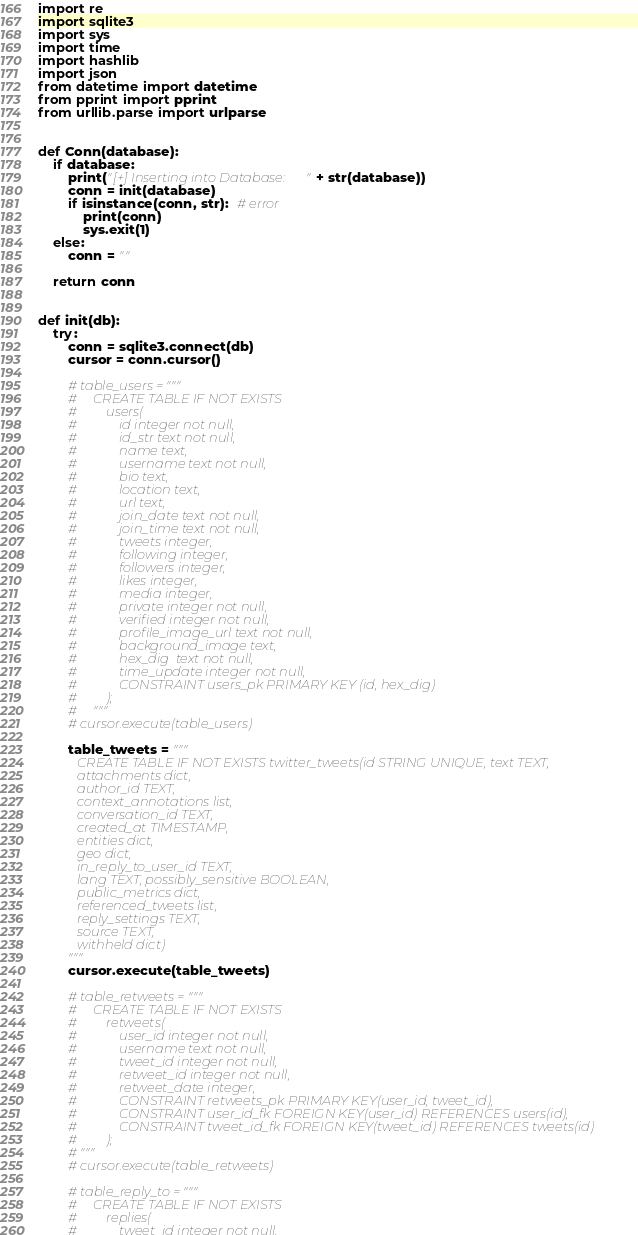<code> <loc_0><loc_0><loc_500><loc_500><_Python_>import re
import sqlite3
import sys
import time
import hashlib
import json
from datetime import datetime
from pprint import pprint
from urllib.parse import urlparse


def Conn(database):
    if database:
        print("[+] Inserting into Database: " + str(database))
        conn = init(database)
        if isinstance(conn, str):  # error
            print(conn)
            sys.exit(1)
    else:
        conn = ""

    return conn


def init(db):
    try:
        conn = sqlite3.connect(db)
        cursor = conn.cursor()

        # table_users = """
        #     CREATE TABLE IF NOT EXISTS
        #         users(
        #             id integer not null,
        #             id_str text not null,
        #             name text,
        #             username text not null,
        #             bio text,
        #             location text,
        #             url text,
        #             join_date text not null,
        #             join_time text not null,
        #             tweets integer,
        #             following integer,
        #             followers integer,
        #             likes integer,
        #             media integer,
        #             private integer not null,
        #             verified integer not null,
        #             profile_image_url text not null,
        #             background_image text,
        #             hex_dig  text not null,
        #             time_update integer not null,
        #             CONSTRAINT users_pk PRIMARY KEY (id, hex_dig)
        #         );
        #     """
        # cursor.execute(table_users)

        table_tweets = """
            CREATE TABLE IF NOT EXISTS twitter_tweets(id STRING UNIQUE, text TEXT,
            attachments dict,
            author_id TEXT,
            context_annotations list,
            conversation_id TEXT,
            created_at TIMESTAMP,
            entities dict,
            geo dict, 
            in_reply_to_user_id TEXT,
            lang TEXT, possibly_sensitive BOOLEAN,
            public_metrics dict,
            referenced_tweets list,
            reply_settings TEXT,
            source TEXT,
            withheld dict)
        """
        cursor.execute(table_tweets)

        # table_retweets = """
        #     CREATE TABLE IF NOT EXISTS
        #         retweets(
        #             user_id integer not null,
        #             username text not null,
        #             tweet_id integer not null,
        #             retweet_id integer not null,
        #             retweet_date integer,
        #             CONSTRAINT retweets_pk PRIMARY KEY(user_id, tweet_id),
        #             CONSTRAINT user_id_fk FOREIGN KEY(user_id) REFERENCES users(id),
        #             CONSTRAINT tweet_id_fk FOREIGN KEY(tweet_id) REFERENCES tweets(id)
        #         );
        # """
        # cursor.execute(table_retweets)

        # table_reply_to = """
        #     CREATE TABLE IF NOT EXISTS
        #         replies(
        #             tweet_id integer not null,</code> 